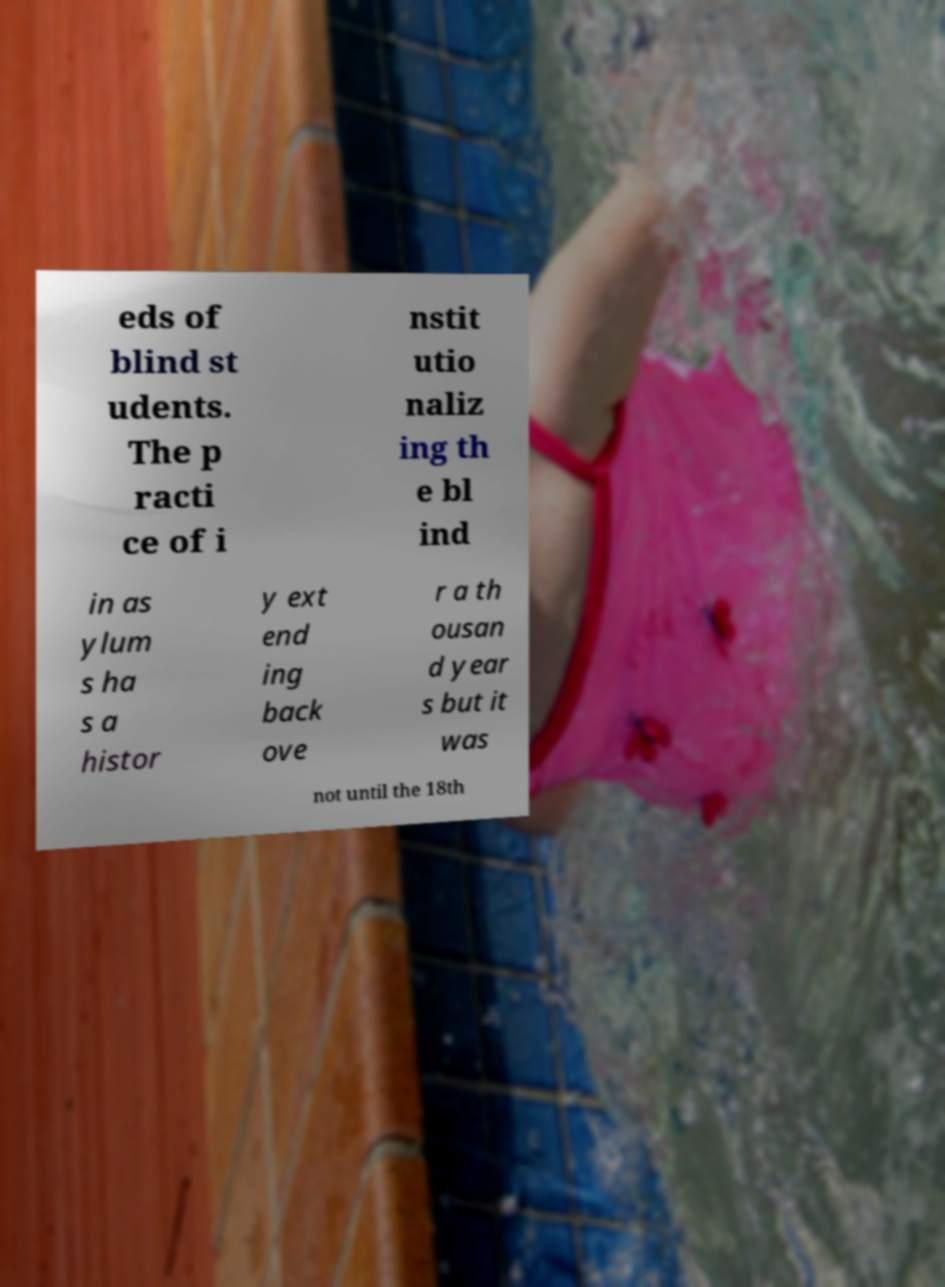Please read and relay the text visible in this image. What does it say? eds of blind st udents. The p racti ce of i nstit utio naliz ing th e bl ind in as ylum s ha s a histor y ext end ing back ove r a th ousan d year s but it was not until the 18th 